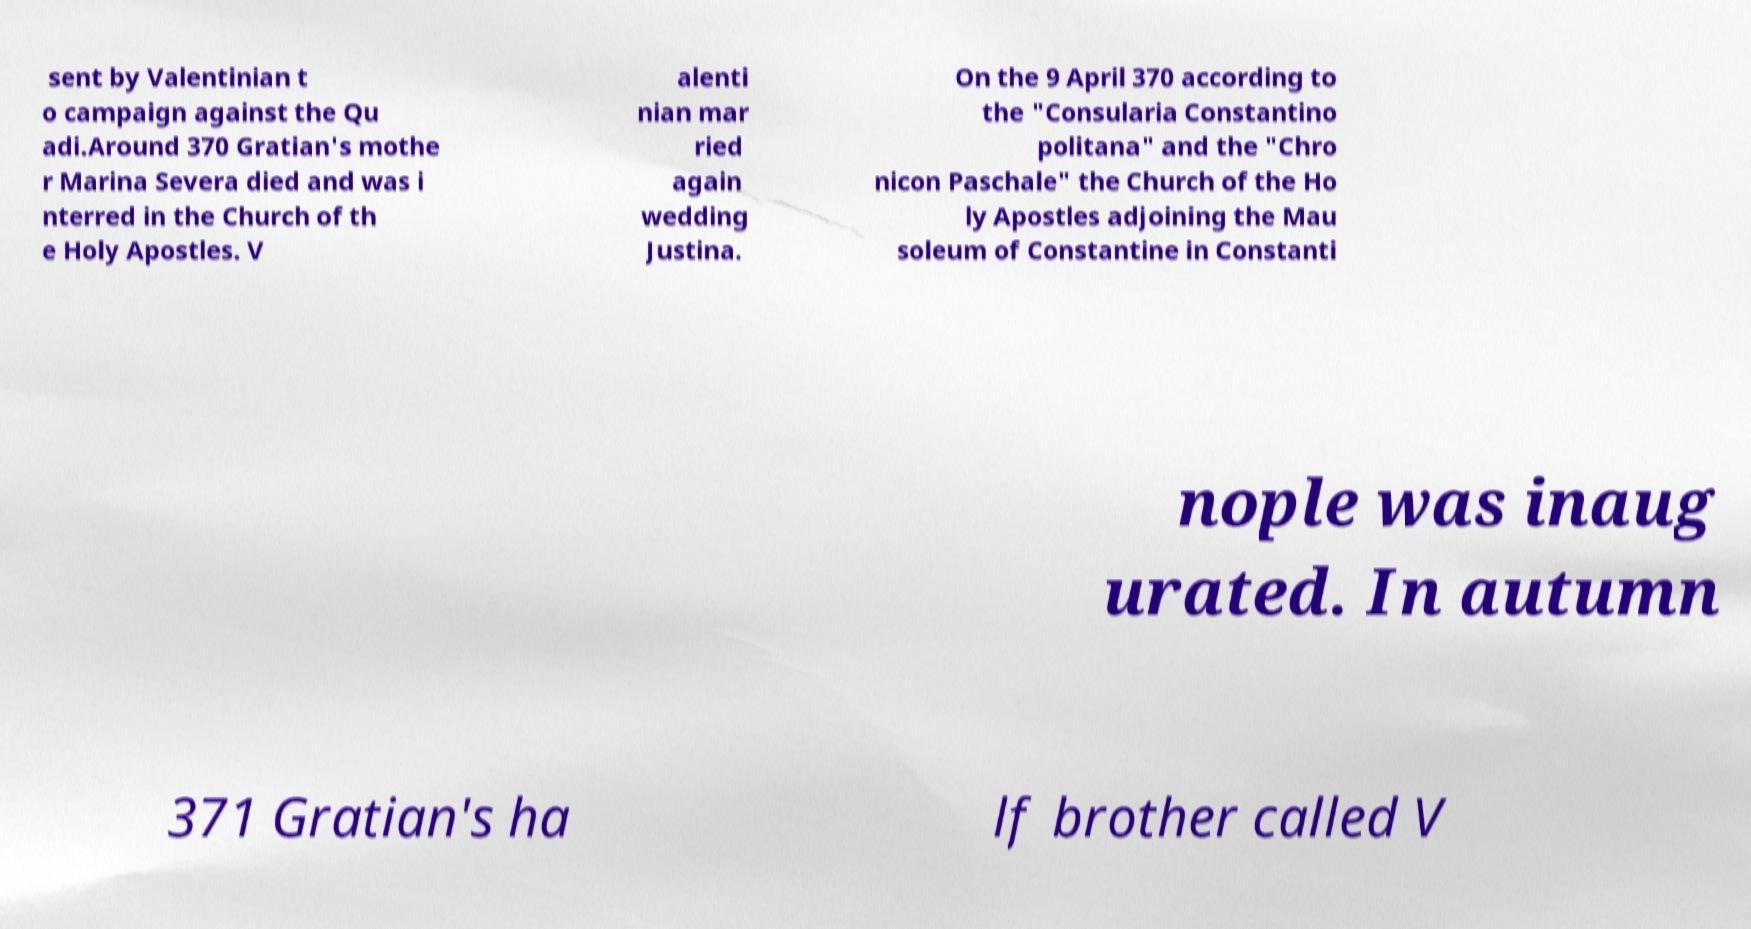Please identify and transcribe the text found in this image. sent by Valentinian t o campaign against the Qu adi.Around 370 Gratian's mothe r Marina Severa died and was i nterred in the Church of th e Holy Apostles. V alenti nian mar ried again wedding Justina. On the 9 April 370 according to the "Consularia Constantino politana" and the "Chro nicon Paschale" the Church of the Ho ly Apostles adjoining the Mau soleum of Constantine in Constanti nople was inaug urated. In autumn 371 Gratian's ha lf brother called V 